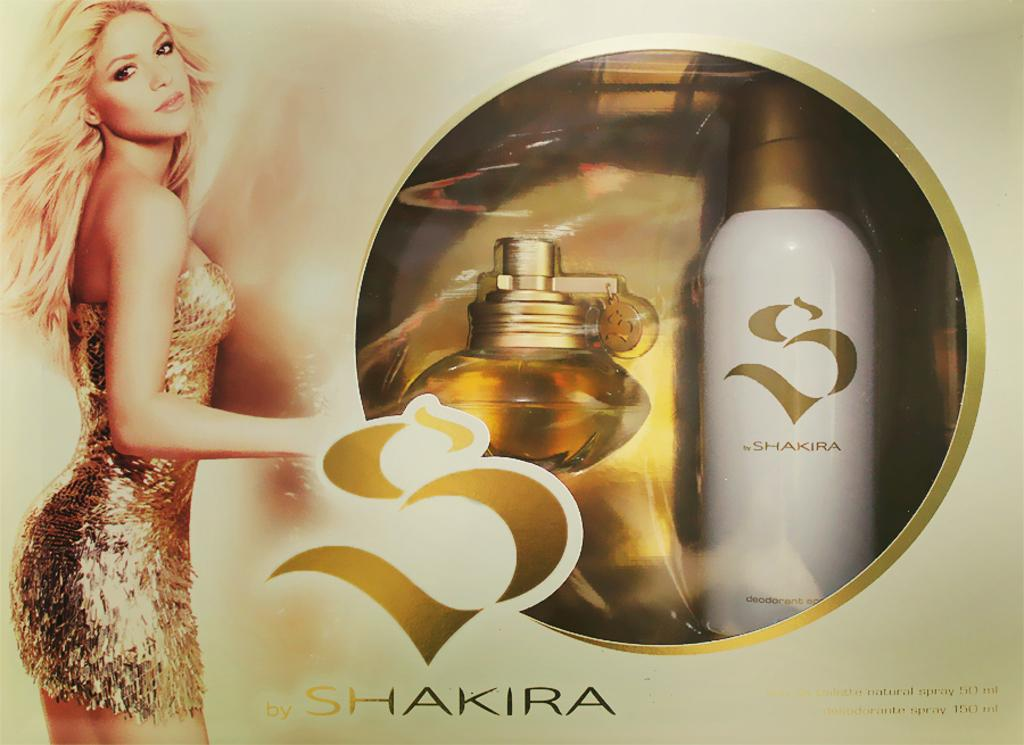<image>
Relay a brief, clear account of the picture shown. An ad for a bottle of perfume by Shakira. 